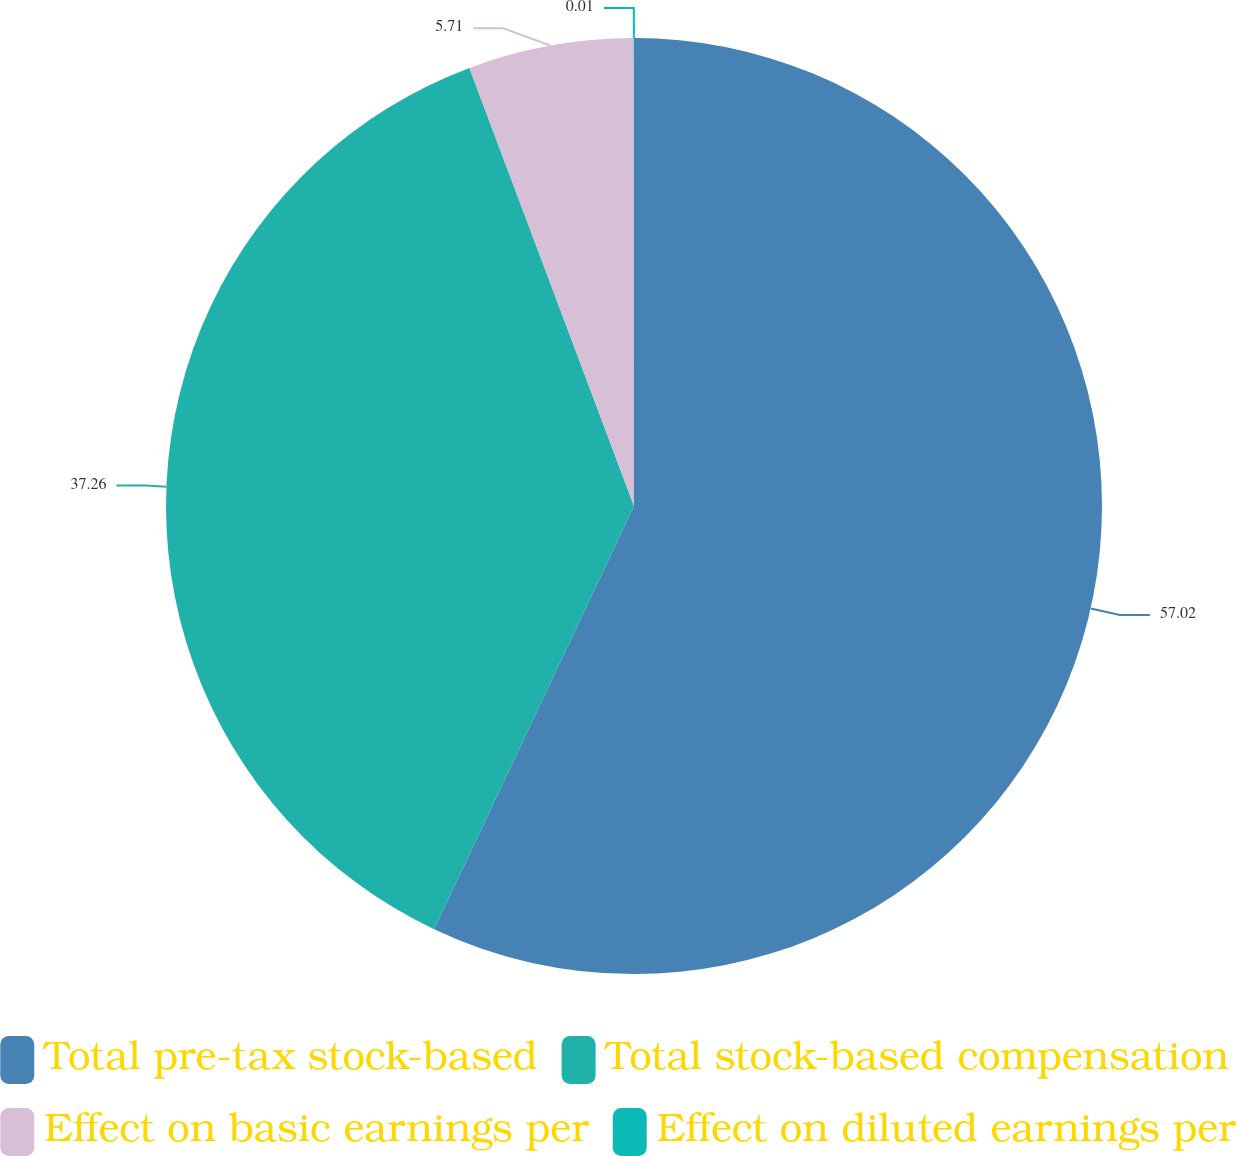Convert chart to OTSL. <chart><loc_0><loc_0><loc_500><loc_500><pie_chart><fcel>Total pre-tax stock-based<fcel>Total stock-based compensation<fcel>Effect on basic earnings per<fcel>Effect on diluted earnings per<nl><fcel>57.03%<fcel>37.26%<fcel>5.71%<fcel>0.01%<nl></chart> 